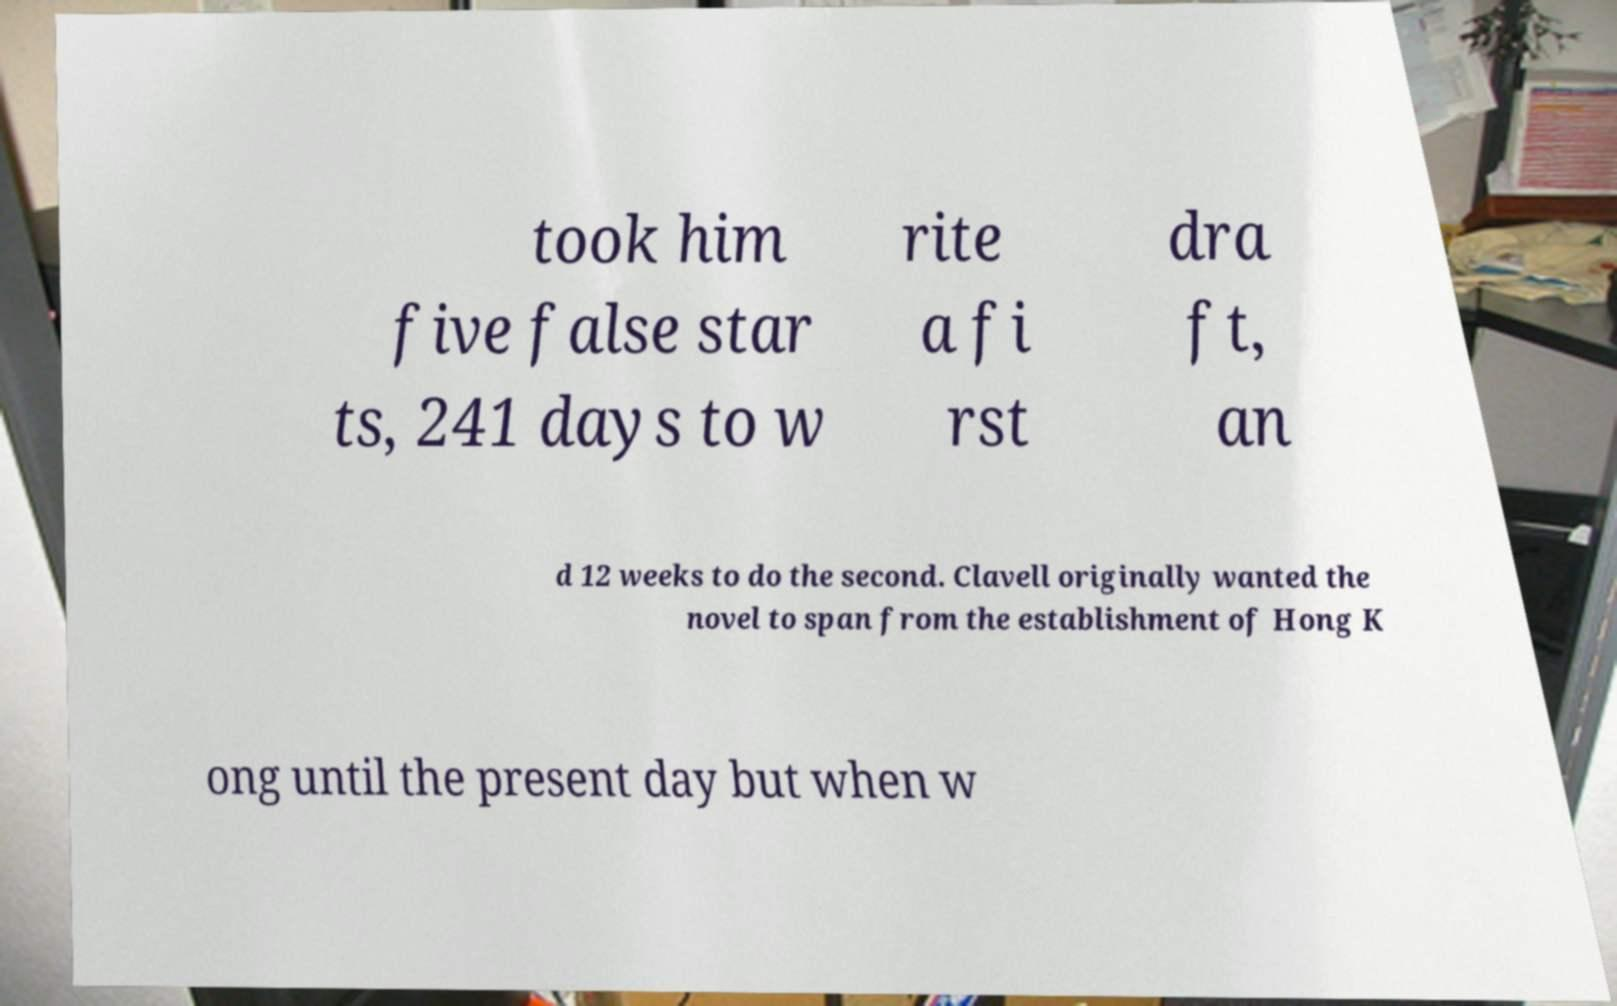Please identify and transcribe the text found in this image. took him five false star ts, 241 days to w rite a fi rst dra ft, an d 12 weeks to do the second. Clavell originally wanted the novel to span from the establishment of Hong K ong until the present day but when w 